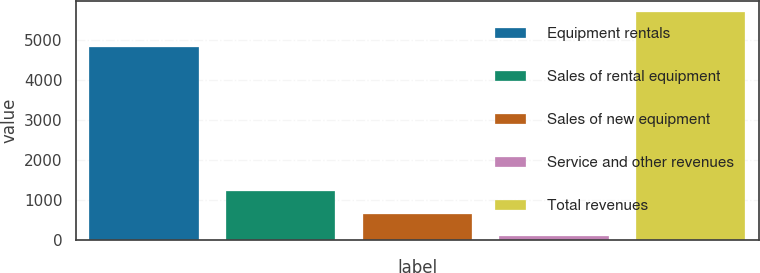Convert chart. <chart><loc_0><loc_0><loc_500><loc_500><bar_chart><fcel>Equipment rentals<fcel>Sales of rental equipment<fcel>Sales of new equipment<fcel>Service and other revenues<fcel>Total revenues<nl><fcel>4819<fcel>1207.4<fcel>647.7<fcel>88<fcel>5685<nl></chart> 